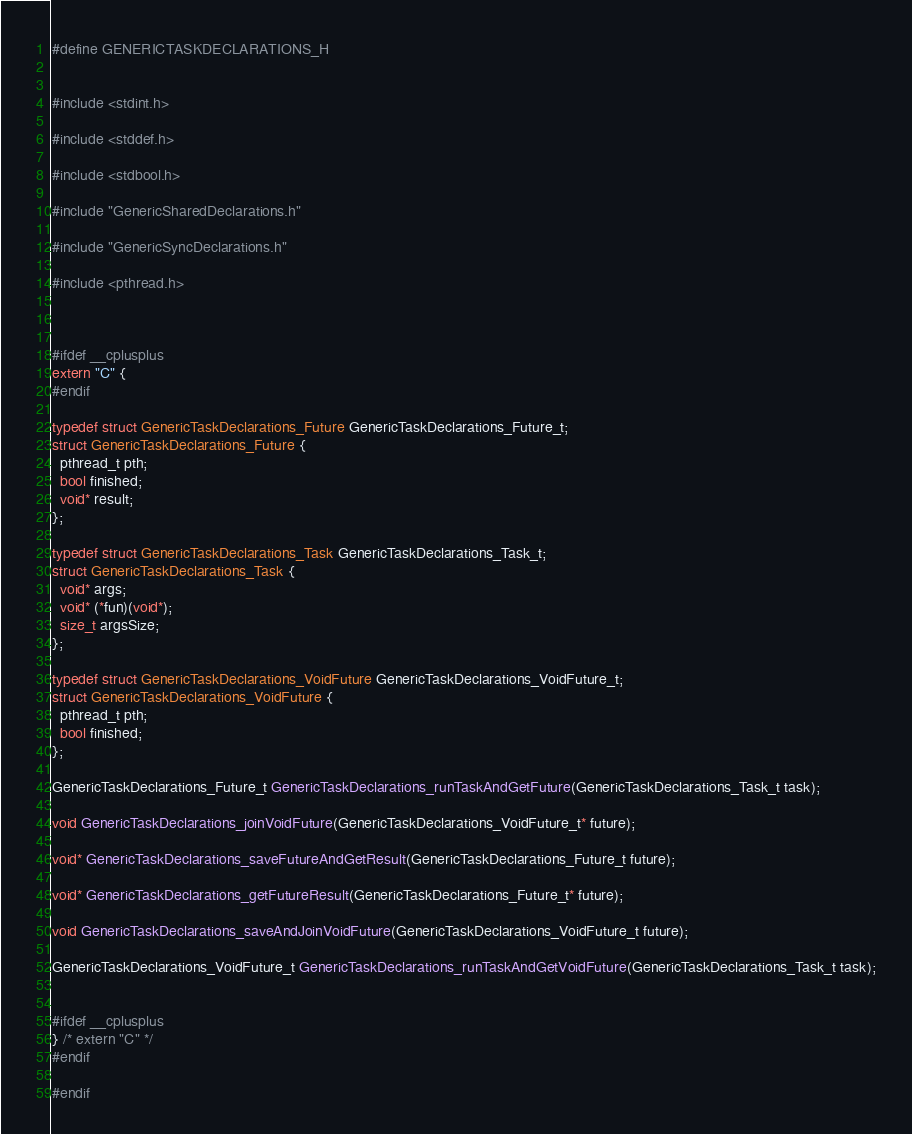<code> <loc_0><loc_0><loc_500><loc_500><_C_>#define GENERICTASKDECLARATIONS_H


#include <stdint.h>

#include <stddef.h>

#include <stdbool.h>

#include "GenericSharedDeclarations.h"

#include "GenericSyncDeclarations.h"

#include <pthread.h>



#ifdef __cplusplus
extern "C" {
#endif

typedef struct GenericTaskDeclarations_Future GenericTaskDeclarations_Future_t;
struct GenericTaskDeclarations_Future {
  pthread_t pth;
  bool finished;
  void* result;
};

typedef struct GenericTaskDeclarations_Task GenericTaskDeclarations_Task_t;
struct GenericTaskDeclarations_Task {
  void* args;
  void* (*fun)(void*);
  size_t argsSize;
};

typedef struct GenericTaskDeclarations_VoidFuture GenericTaskDeclarations_VoidFuture_t;
struct GenericTaskDeclarations_VoidFuture {
  pthread_t pth;
  bool finished;
};

GenericTaskDeclarations_Future_t GenericTaskDeclarations_runTaskAndGetFuture(GenericTaskDeclarations_Task_t task);

void GenericTaskDeclarations_joinVoidFuture(GenericTaskDeclarations_VoidFuture_t* future);

void* GenericTaskDeclarations_saveFutureAndGetResult(GenericTaskDeclarations_Future_t future);

void* GenericTaskDeclarations_getFutureResult(GenericTaskDeclarations_Future_t* future);

void GenericTaskDeclarations_saveAndJoinVoidFuture(GenericTaskDeclarations_VoidFuture_t future);

GenericTaskDeclarations_VoidFuture_t GenericTaskDeclarations_runTaskAndGetVoidFuture(GenericTaskDeclarations_Task_t task);


#ifdef __cplusplus
} /* extern "C" */
#endif

#endif
</code> 